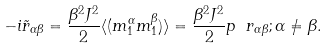<formula> <loc_0><loc_0><loc_500><loc_500>- i { \tilde { r } } _ { \alpha \beta } = \frac { \beta ^ { 2 } J ^ { 2 } } { 2 } \langle ( m ^ { \alpha } _ { 1 } m ^ { \beta } _ { 1 } ) \rangle = \frac { \beta ^ { 2 } J ^ { 2 } } { 2 } p \ r _ { \alpha \beta } ; \alpha \neq \beta .</formula> 